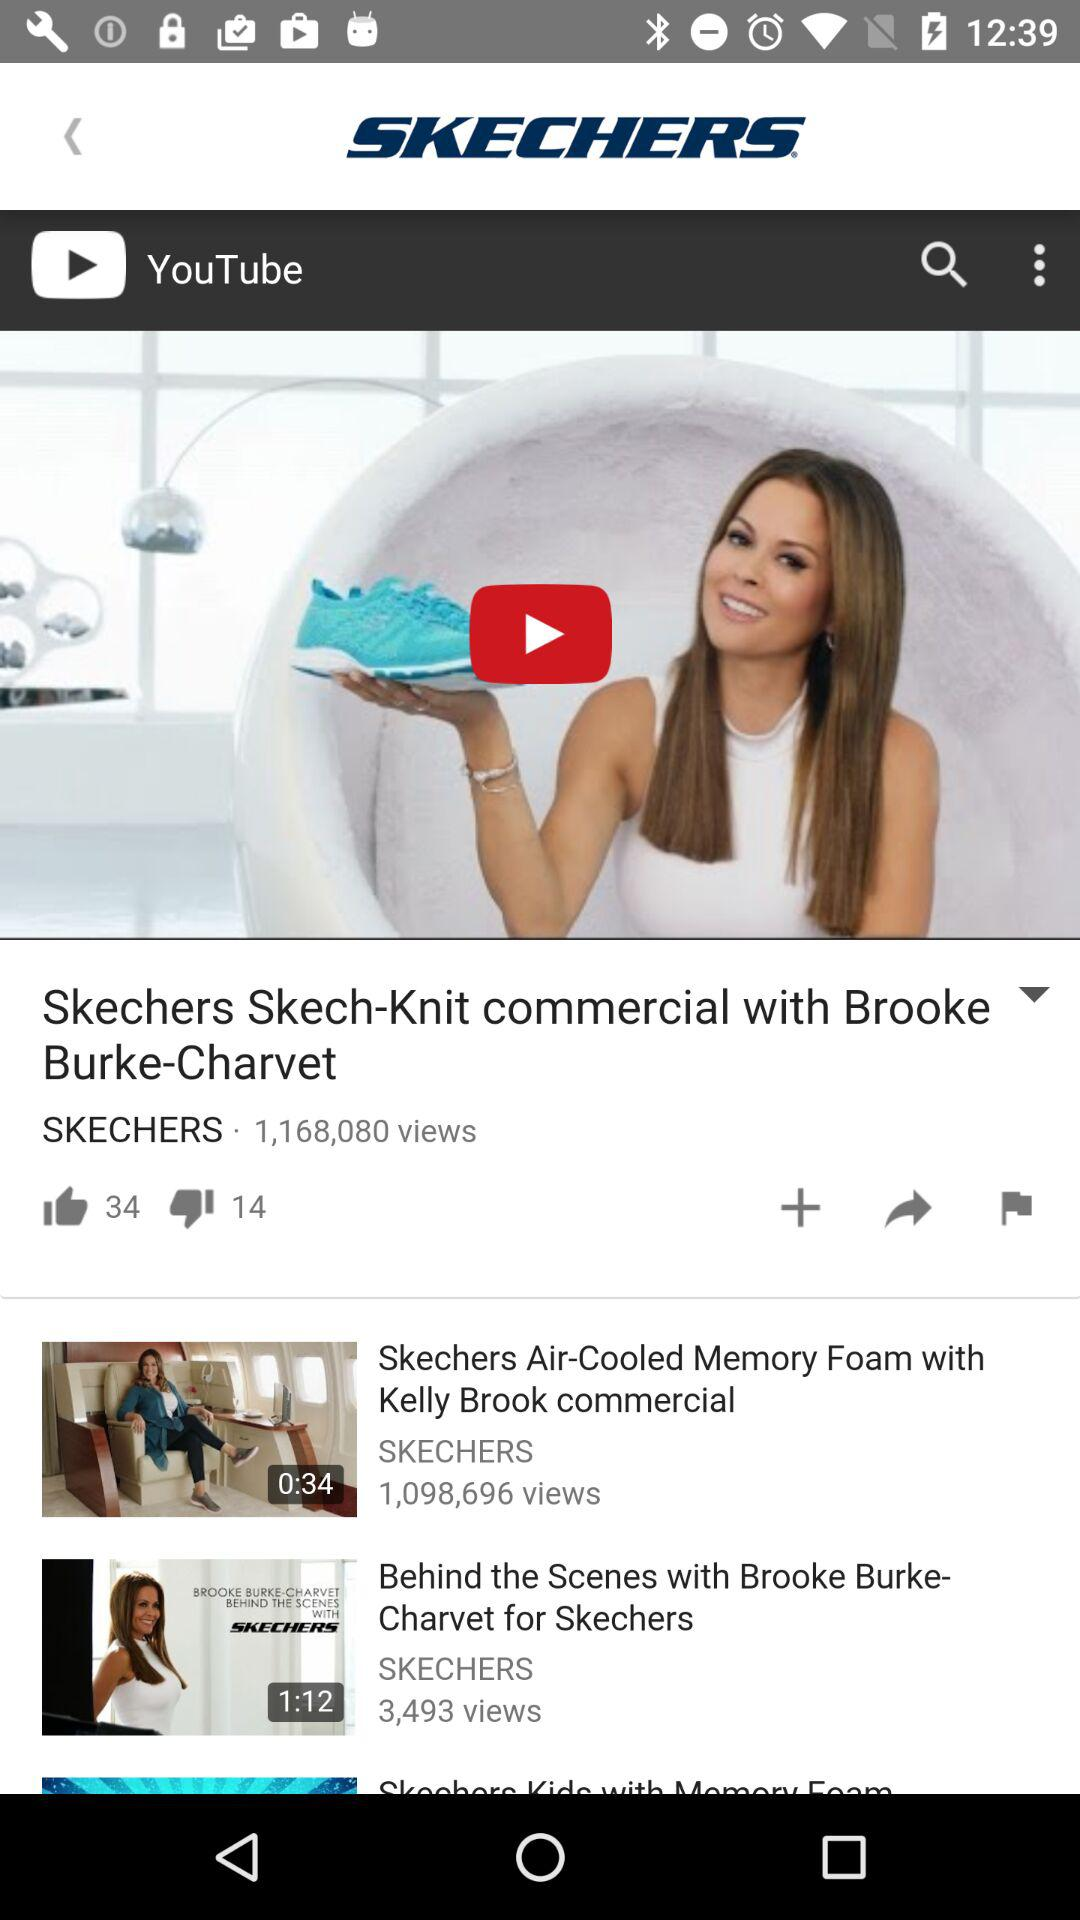How many thumbs up does the first video have?
Answer the question using a single word or phrase. 34 